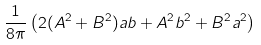<formula> <loc_0><loc_0><loc_500><loc_500>\frac { 1 } { 8 \pi } \left ( 2 ( A ^ { 2 } + B ^ { 2 } ) a b + A ^ { 2 } b ^ { 2 } + B ^ { 2 } a ^ { 2 } \right )</formula> 